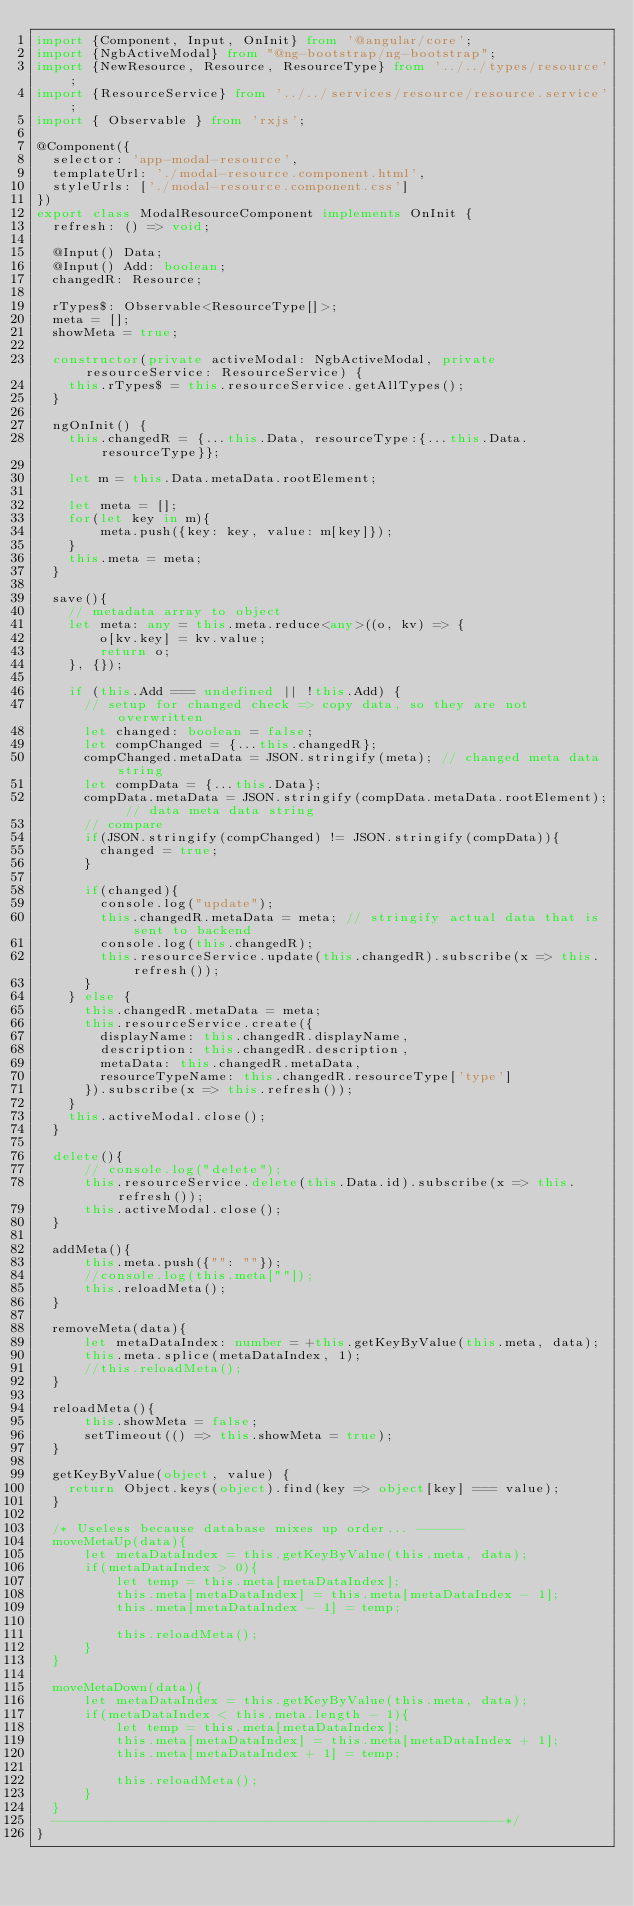Convert code to text. <code><loc_0><loc_0><loc_500><loc_500><_TypeScript_>import {Component, Input, OnInit} from '@angular/core';
import {NgbActiveModal} from "@ng-bootstrap/ng-bootstrap";
import {NewResource, Resource, ResourceType} from '../../types/resource';
import {ResourceService} from '../../services/resource/resource.service';
import { Observable } from 'rxjs';

@Component({
  selector: 'app-modal-resource',
  templateUrl: './modal-resource.component.html',
  styleUrls: ['./modal-resource.component.css']
})
export class ModalResourceComponent implements OnInit {
  refresh: () => void;

  @Input() Data;
  @Input() Add: boolean;
  changedR: Resource;

  rTypes$: Observable<ResourceType[]>;
  meta = [];
  showMeta = true;

  constructor(private activeModal: NgbActiveModal, private resourceService: ResourceService) {
    this.rTypes$ = this.resourceService.getAllTypes();
  }

  ngOnInit() {
    this.changedR = {...this.Data, resourceType:{...this.Data.resourceType}};

    let m = this.Data.metaData.rootElement;

    let meta = [];
    for(let key in m){
        meta.push({key: key, value: m[key]});
    }
    this.meta = meta;
  }

  save(){
    // metadata array to object
    let meta: any = this.meta.reduce<any>((o, kv) => {
        o[kv.key] = kv.value;
        return o;
    }, {});

    if (this.Add === undefined || !this.Add) {
      // setup for changed check => copy data, so they are not overwritten
      let changed: boolean = false;
      let compChanged = {...this.changedR};
      compChanged.metaData = JSON.stringify(meta); // changed meta data string
      let compData = {...this.Data};
      compData.metaData = JSON.stringify(compData.metaData.rootElement); // data meta data string
      // compare
      if(JSON.stringify(compChanged) != JSON.stringify(compData)){
        changed = true;
      }

      if(changed){
        console.log("update");
        this.changedR.metaData = meta; // stringify actual data that is sent to backend
        console.log(this.changedR);
        this.resourceService.update(this.changedR).subscribe(x => this.refresh());
      }
    } else {
      this.changedR.metaData = meta;
      this.resourceService.create({
        displayName: this.changedR.displayName,
        description: this.changedR.description,
        metaData: this.changedR.metaData,
        resourceTypeName: this.changedR.resourceType['type']
      }).subscribe(x => this.refresh());
    }
    this.activeModal.close();
  }

  delete(){
      // console.log("delete");
      this.resourceService.delete(this.Data.id).subscribe(x => this.refresh());
      this.activeModal.close();
  }

  addMeta(){
      this.meta.push({"": ""});
      //console.log(this.meta[""]);
      this.reloadMeta();
  }

  removeMeta(data){
      let metaDataIndex: number = +this.getKeyByValue(this.meta, data);
      this.meta.splice(metaDataIndex, 1);
      //this.reloadMeta();
  }

  reloadMeta(){
      this.showMeta = false;
      setTimeout(() => this.showMeta = true);
  }

  getKeyByValue(object, value) {
    return Object.keys(object).find(key => object[key] === value);
  }

  /* Useless because database mixes up order... ------
  moveMetaUp(data){
      let metaDataIndex = this.getKeyByValue(this.meta, data);
      if(metaDataIndex > 0){
          let temp = this.meta[metaDataIndex];
          this.meta[metaDataIndex] = this.meta[metaDataIndex - 1];
          this.meta[metaDataIndex - 1] = temp;

          this.reloadMeta();
      }
  }

  moveMetaDown(data){
      let metaDataIndex = this.getKeyByValue(this.meta, data);
      if(metaDataIndex < this.meta.length - 1){
          let temp = this.meta[metaDataIndex];
          this.meta[metaDataIndex] = this.meta[metaDataIndex + 1];
          this.meta[metaDataIndex + 1] = temp;

          this.reloadMeta();
      }
  }
  ---------------------------------------------------------*/
}
</code> 